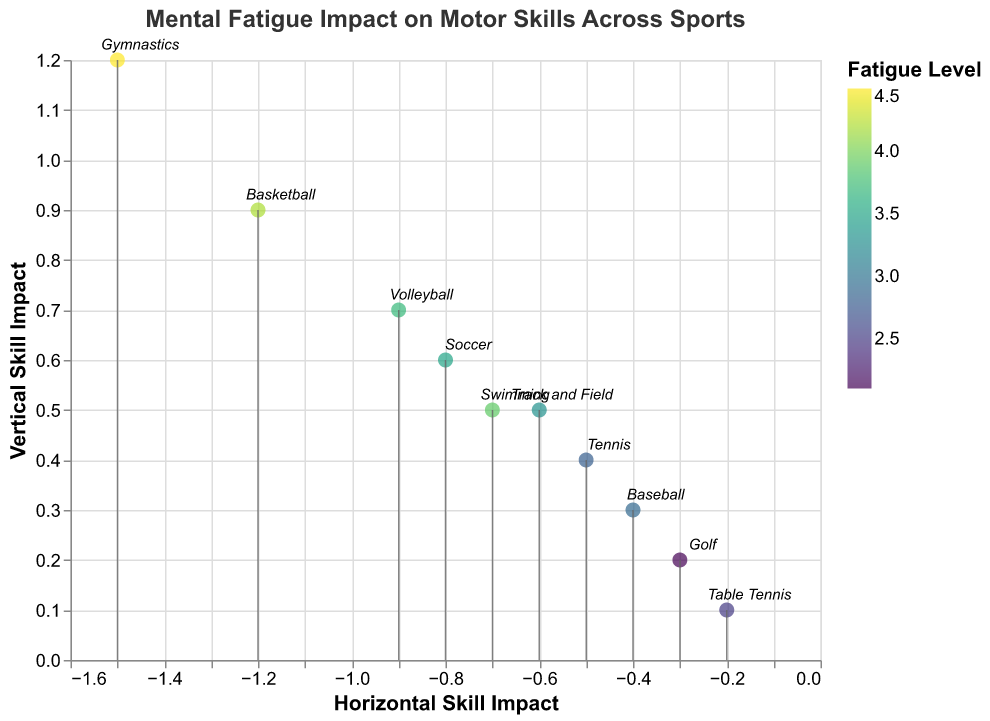what's the title of the figure? The title is written explicitly at the top of the figure. It reads "Mental Fatigue Impact on Motor Skills Across Sports" in bold, large, and colorful text.
Answer: Mental Fatigue Impact on Motor Skills Across Sports how many sports disciplines are displayed in the figure? The markers denote each sports discipline, and each is labeled with its sport name. Counting these markers reveals there are 10 different sports.
Answer: 10 which sport has the highest fatigue level? By examining the color range (mapped to fatigue level) and the tooltips or labels associated with the points, the sport with the darkest color corresponding to the highest fatigue level is Gymnastics at 4.5.
Answer: Gymnastics which two sports show the smallest horizontal and vertical skill impacts respectively? Find the points closest to the origin (0,0) on both axes. Table Tennis shows the smallest horizontal impact at -0.2, and Golf shows the smallest vertical impact at 0.2.
Answer: Table Tennis (horizontal), Golf (vertical) which sport has the most negative performance change? By inspecting performance change via tooltips, Gymnastics shows the highest negative performance change at -25.
Answer: Gymnastics what's the combined impact (sum) of horizontal skill impacts for Swimming and Track and Field? The horizontal impacts for Swimming and Track and Field are -0.7 and -0.6 respectively. The sum is -0.7 + -0.6 = -1.3
Answer: -1.3 which sport experiences a skill impact in the positive y-axis direction but negative x-axis direction? Points with positive y-values but negative x-values indicate this condition. Sports like Soccer (-0.8, 0.6) and Basketball (-1.2, 0.9) meet this criterion.
Answer: Soccer, Basketball how does skill impact vary for Basketball and Tennis, and which has higher performance change? Basketball has impacts of (-1.2, 0.9) with -22% performance change while Tennis has impacts of (-0.5, 0.4) with -10% performance change. Basketball has both higher skill impact and higher performance change.
Answer: Basketball what is the average fatigue level across all sports in the figure? Sum all the fatigue levels and divide by the number of sports: (3.5 + 4.2 + 2.8 + 3.9 + 4.5 + 2.1 + 3.7 + 3.3 + 2.9 + 2.5)/10 = 33.4/10 = 3.34.
Answer: 3.34 